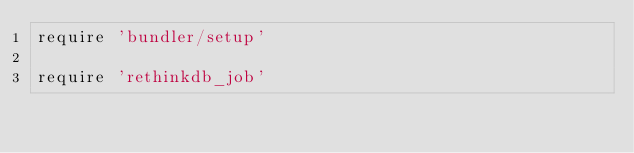<code> <loc_0><loc_0><loc_500><loc_500><_Ruby_>require 'bundler/setup'

require 'rethinkdb_job'
</code> 